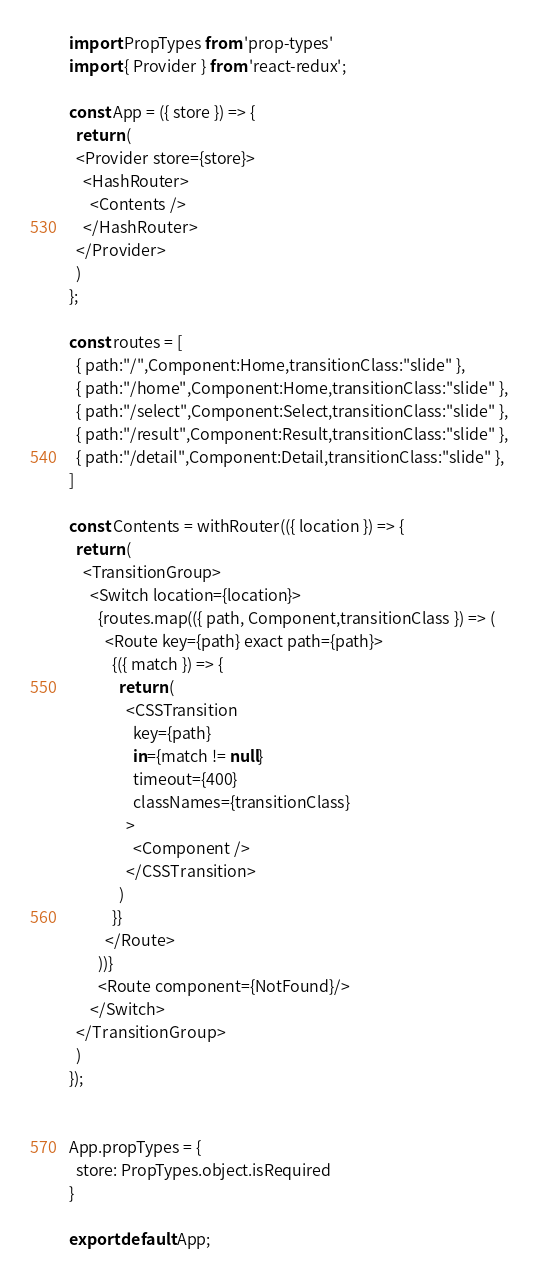Convert code to text. <code><loc_0><loc_0><loc_500><loc_500><_JavaScript_>
import PropTypes from 'prop-types'
import { Provider } from 'react-redux';

const App = ({ store }) => {
  return (
  <Provider store={store}>
    <HashRouter>
      <Contents />
    </HashRouter>
  </Provider>
  )
};

const routes = [
  { path:"/",Component:Home,transitionClass:"slide" },
  { path:"/home",Component:Home,transitionClass:"slide" },
  { path:"/select",Component:Select,transitionClass:"slide" },
  { path:"/result",Component:Result,transitionClass:"slide" },
  { path:"/detail",Component:Detail,transitionClass:"slide" },
]

const Contents = withRouter(({ location }) => {
  return (
    <TransitionGroup>
      <Switch location={location}>
        {routes.map(({ path, Component,transitionClass }) => (
          <Route key={path} exact path={path}>
            {({ match }) => {
              return (
                <CSSTransition
                  key={path}
                  in={match != null}
                  timeout={400}
                  classNames={transitionClass}
                >
                  <Component />
                </CSSTransition>
              )
            }}
          </Route>              
        ))}
        <Route component={NotFound}/>
      </Switch>
  </TransitionGroup>
  )
});


App.propTypes = {
  store: PropTypes.object.isRequired
}

export default App;</code> 